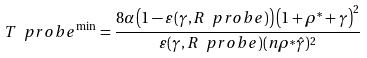<formula> <loc_0><loc_0><loc_500><loc_500>T \ p r o b e ^ { \min } = \frac { 8 \alpha \left ( 1 - \varepsilon ( \gamma , R \ p r o b e ) \right ) \left ( 1 + \rho ^ { * } + \gamma \right ) ^ { 2 } } { \varepsilon ( \gamma , R \ p r o b e ) ( n \rho ^ { * } \hat { \gamma } ) ^ { 2 } }</formula> 